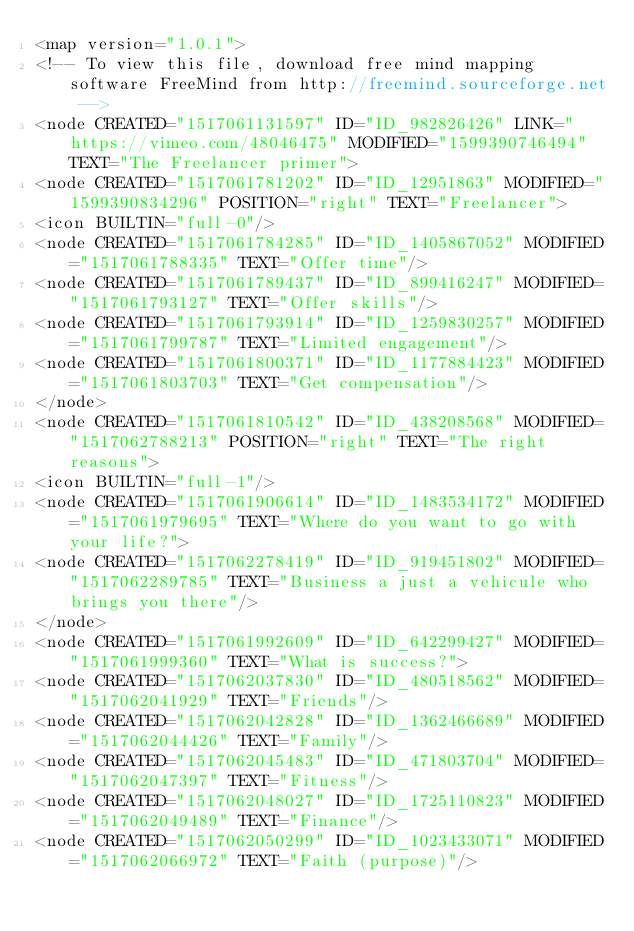<code> <loc_0><loc_0><loc_500><loc_500><_ObjectiveC_><map version="1.0.1">
<!-- To view this file, download free mind mapping software FreeMind from http://freemind.sourceforge.net -->
<node CREATED="1517061131597" ID="ID_982826426" LINK="https://vimeo.com/48046475" MODIFIED="1599390746494" TEXT="The Freelancer primer">
<node CREATED="1517061781202" ID="ID_12951863" MODIFIED="1599390834296" POSITION="right" TEXT="Freelancer">
<icon BUILTIN="full-0"/>
<node CREATED="1517061784285" ID="ID_1405867052" MODIFIED="1517061788335" TEXT="Offer time"/>
<node CREATED="1517061789437" ID="ID_899416247" MODIFIED="1517061793127" TEXT="Offer skills"/>
<node CREATED="1517061793914" ID="ID_1259830257" MODIFIED="1517061799787" TEXT="Limited engagement"/>
<node CREATED="1517061800371" ID="ID_1177884423" MODIFIED="1517061803703" TEXT="Get compensation"/>
</node>
<node CREATED="1517061810542" ID="ID_438208568" MODIFIED="1517062788213" POSITION="right" TEXT="The right reasons">
<icon BUILTIN="full-1"/>
<node CREATED="1517061906614" ID="ID_1483534172" MODIFIED="1517061979695" TEXT="Where do you want to go with your life?">
<node CREATED="1517062278419" ID="ID_919451802" MODIFIED="1517062289785" TEXT="Business a just a vehicule who brings you there"/>
</node>
<node CREATED="1517061992609" ID="ID_642299427" MODIFIED="1517061999360" TEXT="What is success?">
<node CREATED="1517062037830" ID="ID_480518562" MODIFIED="1517062041929" TEXT="Friends"/>
<node CREATED="1517062042828" ID="ID_1362466689" MODIFIED="1517062044426" TEXT="Family"/>
<node CREATED="1517062045483" ID="ID_471803704" MODIFIED="1517062047397" TEXT="Fitness"/>
<node CREATED="1517062048027" ID="ID_1725110823" MODIFIED="1517062049489" TEXT="Finance"/>
<node CREATED="1517062050299" ID="ID_1023433071" MODIFIED="1517062066972" TEXT="Faith (purpose)"/></code> 